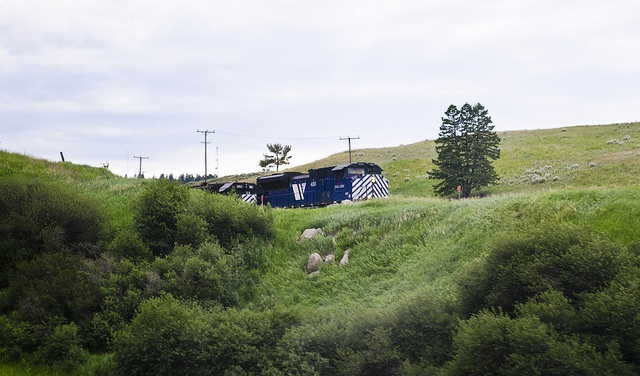Describe the objects in this image and their specific colors. I can see train in white, black, navy, lightgray, and darkgray tones, sheep in white, darkgray, gray, and darkgreen tones, and sheep in white, darkgray, lightgray, and gray tones in this image. 